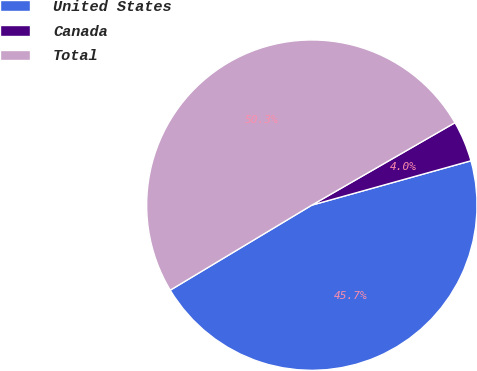<chart> <loc_0><loc_0><loc_500><loc_500><pie_chart><fcel>United States<fcel>Canada<fcel>Total<nl><fcel>45.72%<fcel>3.99%<fcel>50.29%<nl></chart> 